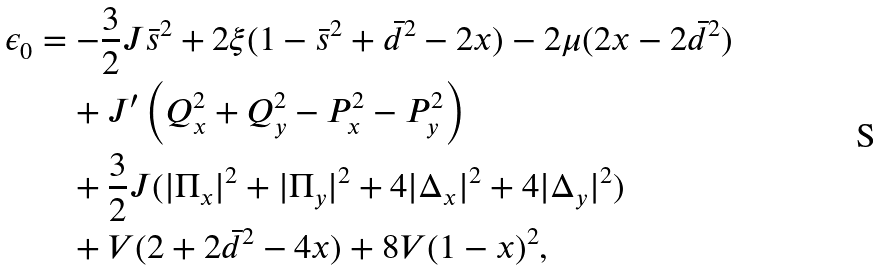<formula> <loc_0><loc_0><loc_500><loc_500>\epsilon _ { 0 } & = - \frac { 3 } { 2 } J \bar { s } ^ { 2 } + 2 \xi ( 1 - \bar { s } ^ { 2 } + \bar { d } ^ { 2 } - 2 x ) - 2 \mu ( 2 x - 2 \bar { d } ^ { 2 } ) \\ & \quad + J ^ { \prime } \left ( Q _ { x } ^ { 2 } + Q _ { y } ^ { 2 } - P _ { x } ^ { 2 } - P _ { y } ^ { 2 } \right ) \\ & \quad + \frac { 3 } { 2 } J ( | \Pi _ { x } | ^ { 2 } + | \Pi _ { y } | ^ { 2 } + 4 | \Delta _ { x } | ^ { 2 } + 4 | \Delta _ { y } | ^ { 2 } ) \\ & \quad + V ( 2 + 2 \bar { d } ^ { 2 } - 4 x ) + 8 V ( 1 - x ) ^ { 2 } ,</formula> 